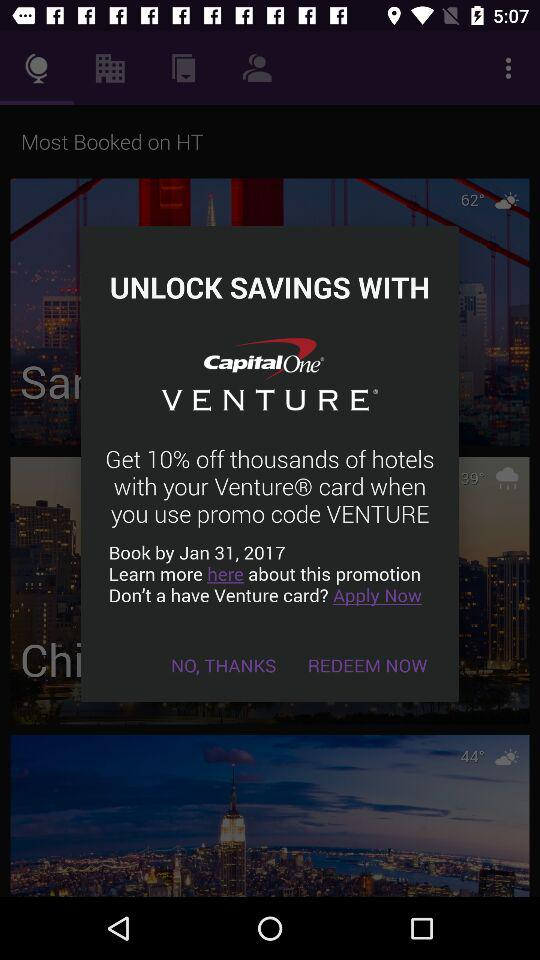How can we unlock the savings? We can unlock the savings by using "CapitalOne VENTURE". 